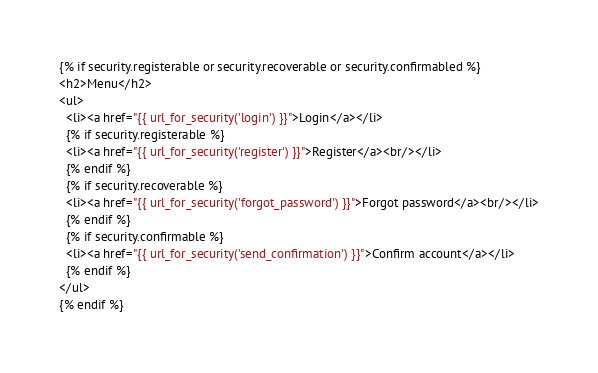<code> <loc_0><loc_0><loc_500><loc_500><_HTML_>
{% if security.registerable or security.recoverable or security.confirmabled %}
<h2>Menu</h2>
<ul>
  <li><a href="{{ url_for_security('login') }}">Login</a></li>
  {% if security.registerable %}
  <li><a href="{{ url_for_security('register') }}">Register</a><br/></li>
  {% endif %}
  {% if security.recoverable %}
  <li><a href="{{ url_for_security('forgot_password') }}">Forgot password</a><br/></li>
  {% endif %}
  {% if security.confirmable %}
  <li><a href="{{ url_for_security('send_confirmation') }}">Confirm account</a></li>
  {% endif %}
</ul>
{% endif %}
</code> 